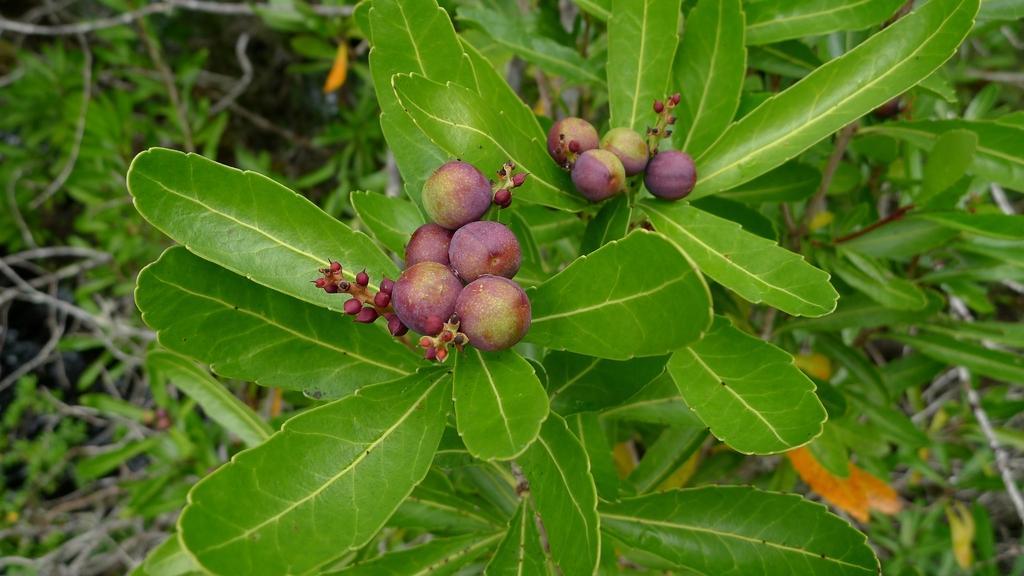Could you give a brief overview of what you see in this image? In this picture I can observe purple and green color fruits. I can observe plants. The background is partially blurred. 